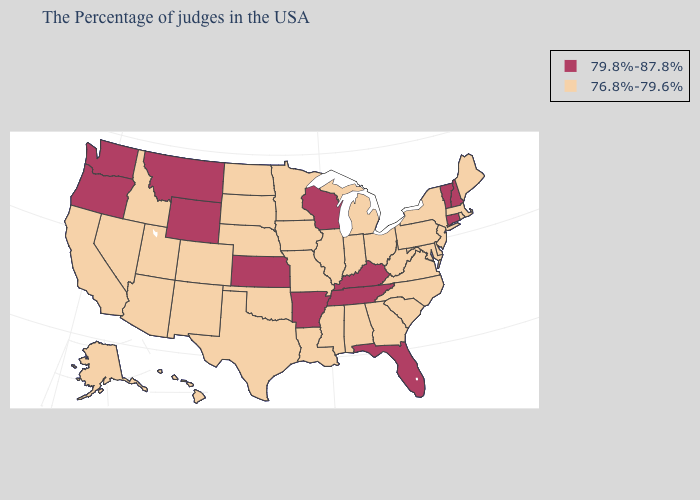Name the states that have a value in the range 79.8%-87.8%?
Concise answer only. New Hampshire, Vermont, Connecticut, Florida, Kentucky, Tennessee, Wisconsin, Arkansas, Kansas, Wyoming, Montana, Washington, Oregon. Does the map have missing data?
Write a very short answer. No. Name the states that have a value in the range 76.8%-79.6%?
Answer briefly. Maine, Massachusetts, Rhode Island, New York, New Jersey, Delaware, Maryland, Pennsylvania, Virginia, North Carolina, South Carolina, West Virginia, Ohio, Georgia, Michigan, Indiana, Alabama, Illinois, Mississippi, Louisiana, Missouri, Minnesota, Iowa, Nebraska, Oklahoma, Texas, South Dakota, North Dakota, Colorado, New Mexico, Utah, Arizona, Idaho, Nevada, California, Alaska, Hawaii. What is the lowest value in the Northeast?
Be succinct. 76.8%-79.6%. What is the value of Wisconsin?
Keep it brief. 79.8%-87.8%. What is the highest value in the USA?
Quick response, please. 79.8%-87.8%. Name the states that have a value in the range 76.8%-79.6%?
Write a very short answer. Maine, Massachusetts, Rhode Island, New York, New Jersey, Delaware, Maryland, Pennsylvania, Virginia, North Carolina, South Carolina, West Virginia, Ohio, Georgia, Michigan, Indiana, Alabama, Illinois, Mississippi, Louisiana, Missouri, Minnesota, Iowa, Nebraska, Oklahoma, Texas, South Dakota, North Dakota, Colorado, New Mexico, Utah, Arizona, Idaho, Nevada, California, Alaska, Hawaii. Which states hav the highest value in the MidWest?
Short answer required. Wisconsin, Kansas. Among the states that border Massachusetts , which have the lowest value?
Short answer required. Rhode Island, New York. Name the states that have a value in the range 76.8%-79.6%?
Give a very brief answer. Maine, Massachusetts, Rhode Island, New York, New Jersey, Delaware, Maryland, Pennsylvania, Virginia, North Carolina, South Carolina, West Virginia, Ohio, Georgia, Michigan, Indiana, Alabama, Illinois, Mississippi, Louisiana, Missouri, Minnesota, Iowa, Nebraska, Oklahoma, Texas, South Dakota, North Dakota, Colorado, New Mexico, Utah, Arizona, Idaho, Nevada, California, Alaska, Hawaii. What is the lowest value in the West?
Keep it brief. 76.8%-79.6%. Name the states that have a value in the range 76.8%-79.6%?
Short answer required. Maine, Massachusetts, Rhode Island, New York, New Jersey, Delaware, Maryland, Pennsylvania, Virginia, North Carolina, South Carolina, West Virginia, Ohio, Georgia, Michigan, Indiana, Alabama, Illinois, Mississippi, Louisiana, Missouri, Minnesota, Iowa, Nebraska, Oklahoma, Texas, South Dakota, North Dakota, Colorado, New Mexico, Utah, Arizona, Idaho, Nevada, California, Alaska, Hawaii. Among the states that border Arkansas , does Tennessee have the lowest value?
Answer briefly. No. Which states have the lowest value in the USA?
Concise answer only. Maine, Massachusetts, Rhode Island, New York, New Jersey, Delaware, Maryland, Pennsylvania, Virginia, North Carolina, South Carolina, West Virginia, Ohio, Georgia, Michigan, Indiana, Alabama, Illinois, Mississippi, Louisiana, Missouri, Minnesota, Iowa, Nebraska, Oklahoma, Texas, South Dakota, North Dakota, Colorado, New Mexico, Utah, Arizona, Idaho, Nevada, California, Alaska, Hawaii. 